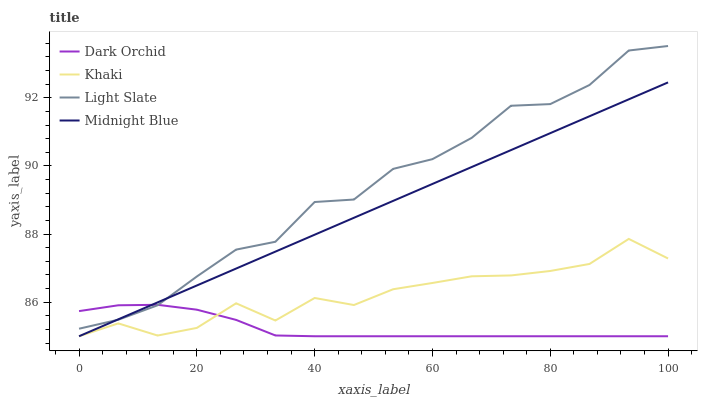Does Dark Orchid have the minimum area under the curve?
Answer yes or no. Yes. Does Light Slate have the maximum area under the curve?
Answer yes or no. Yes. Does Khaki have the minimum area under the curve?
Answer yes or no. No. Does Khaki have the maximum area under the curve?
Answer yes or no. No. Is Midnight Blue the smoothest?
Answer yes or no. Yes. Is Khaki the roughest?
Answer yes or no. Yes. Is Khaki the smoothest?
Answer yes or no. No. Is Midnight Blue the roughest?
Answer yes or no. No. Does Khaki have the highest value?
Answer yes or no. No. Is Khaki less than Light Slate?
Answer yes or no. Yes. Is Light Slate greater than Khaki?
Answer yes or no. Yes. Does Khaki intersect Light Slate?
Answer yes or no. No. 